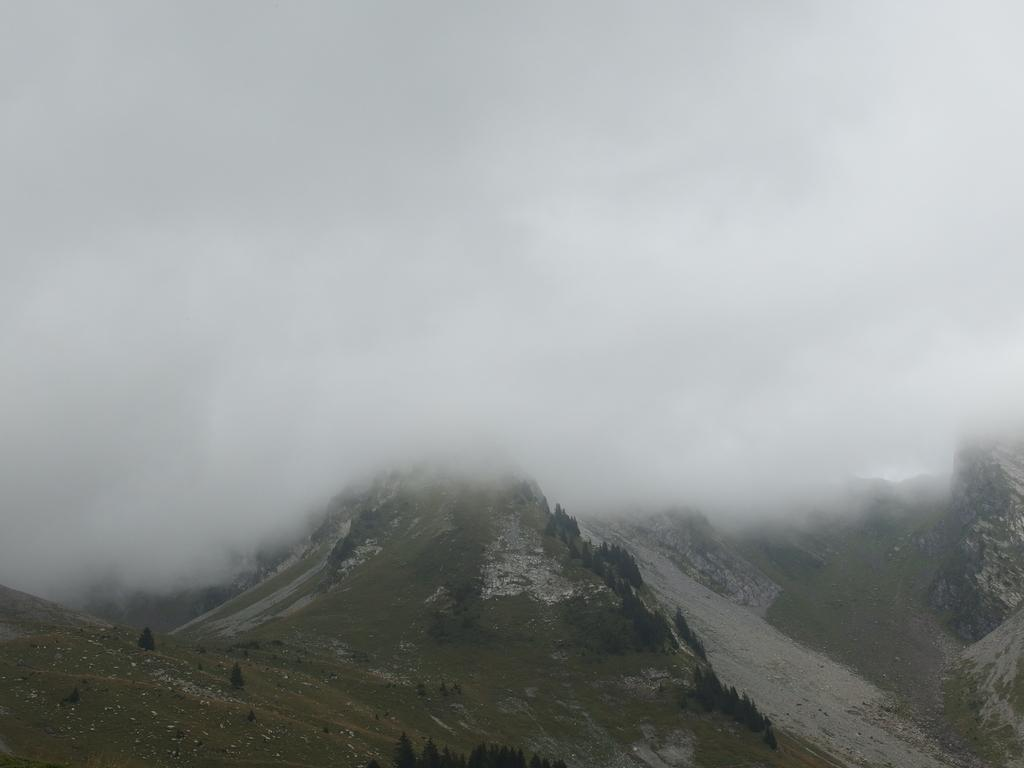What type of landscape is depicted in the image? The image features hills. What can be seen on the hills? There are trees on the hills. What atmospheric condition is present in the image? There is fog visible in the image. What color is the sweater worn by the tree on the hill? There is no sweater present on the tree in the image, as trees do not wear clothing. 